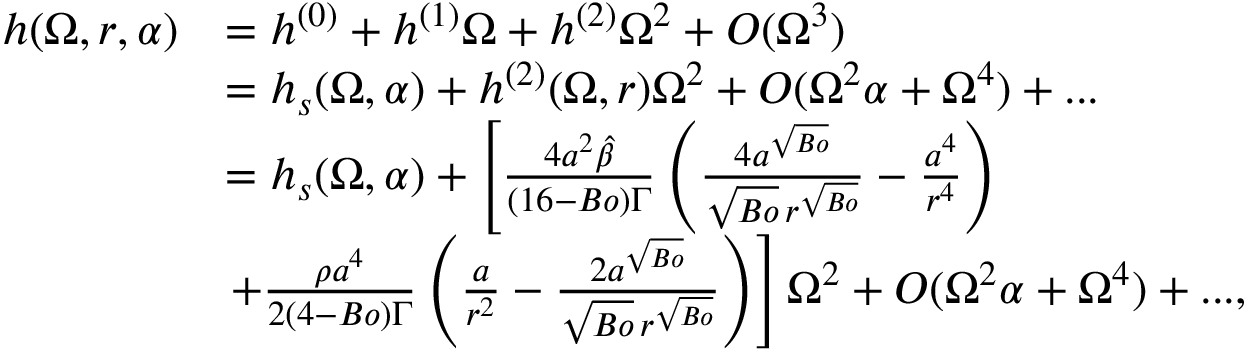Convert formula to latex. <formula><loc_0><loc_0><loc_500><loc_500>\begin{array} { r l } { h ( \Omega , r , \alpha ) } & { = h ^ { ( 0 ) } + h ^ { ( 1 ) } \Omega + h ^ { ( 2 ) } \Omega ^ { 2 } + O ( \Omega ^ { 3 } ) } \\ & { = h _ { s } ( \Omega , \alpha ) + h ^ { ( 2 ) } ( \Omega , r ) \Omega ^ { 2 } + O ( \Omega ^ { 2 } \alpha + \Omega ^ { 4 } ) + \dots } \\ & { = h _ { s } ( \Omega , \alpha ) + \left [ \frac { 4 a ^ { 2 } \hat { \beta } } { ( 1 6 - B o ) \Gamma } \left ( \frac { 4 a ^ { \sqrt { B o } } } { \sqrt { B o } \, r ^ { \sqrt { B o } } } - \frac { a ^ { 4 } } { r ^ { 4 } } \right ) } \\ & { + \frac { \rho { a } ^ { 4 } } { 2 ( 4 - B o ) \Gamma } \left ( \frac { a } { r ^ { 2 } } - \frac { 2 a ^ { \sqrt { B o } } } { \sqrt { B o } \, r ^ { \sqrt { B o } } } \right ) \right ] { \Omega ^ { 2 } } + O ( \Omega ^ { 2 } \alpha + \Omega ^ { 4 } ) + \dots , } \end{array}</formula> 